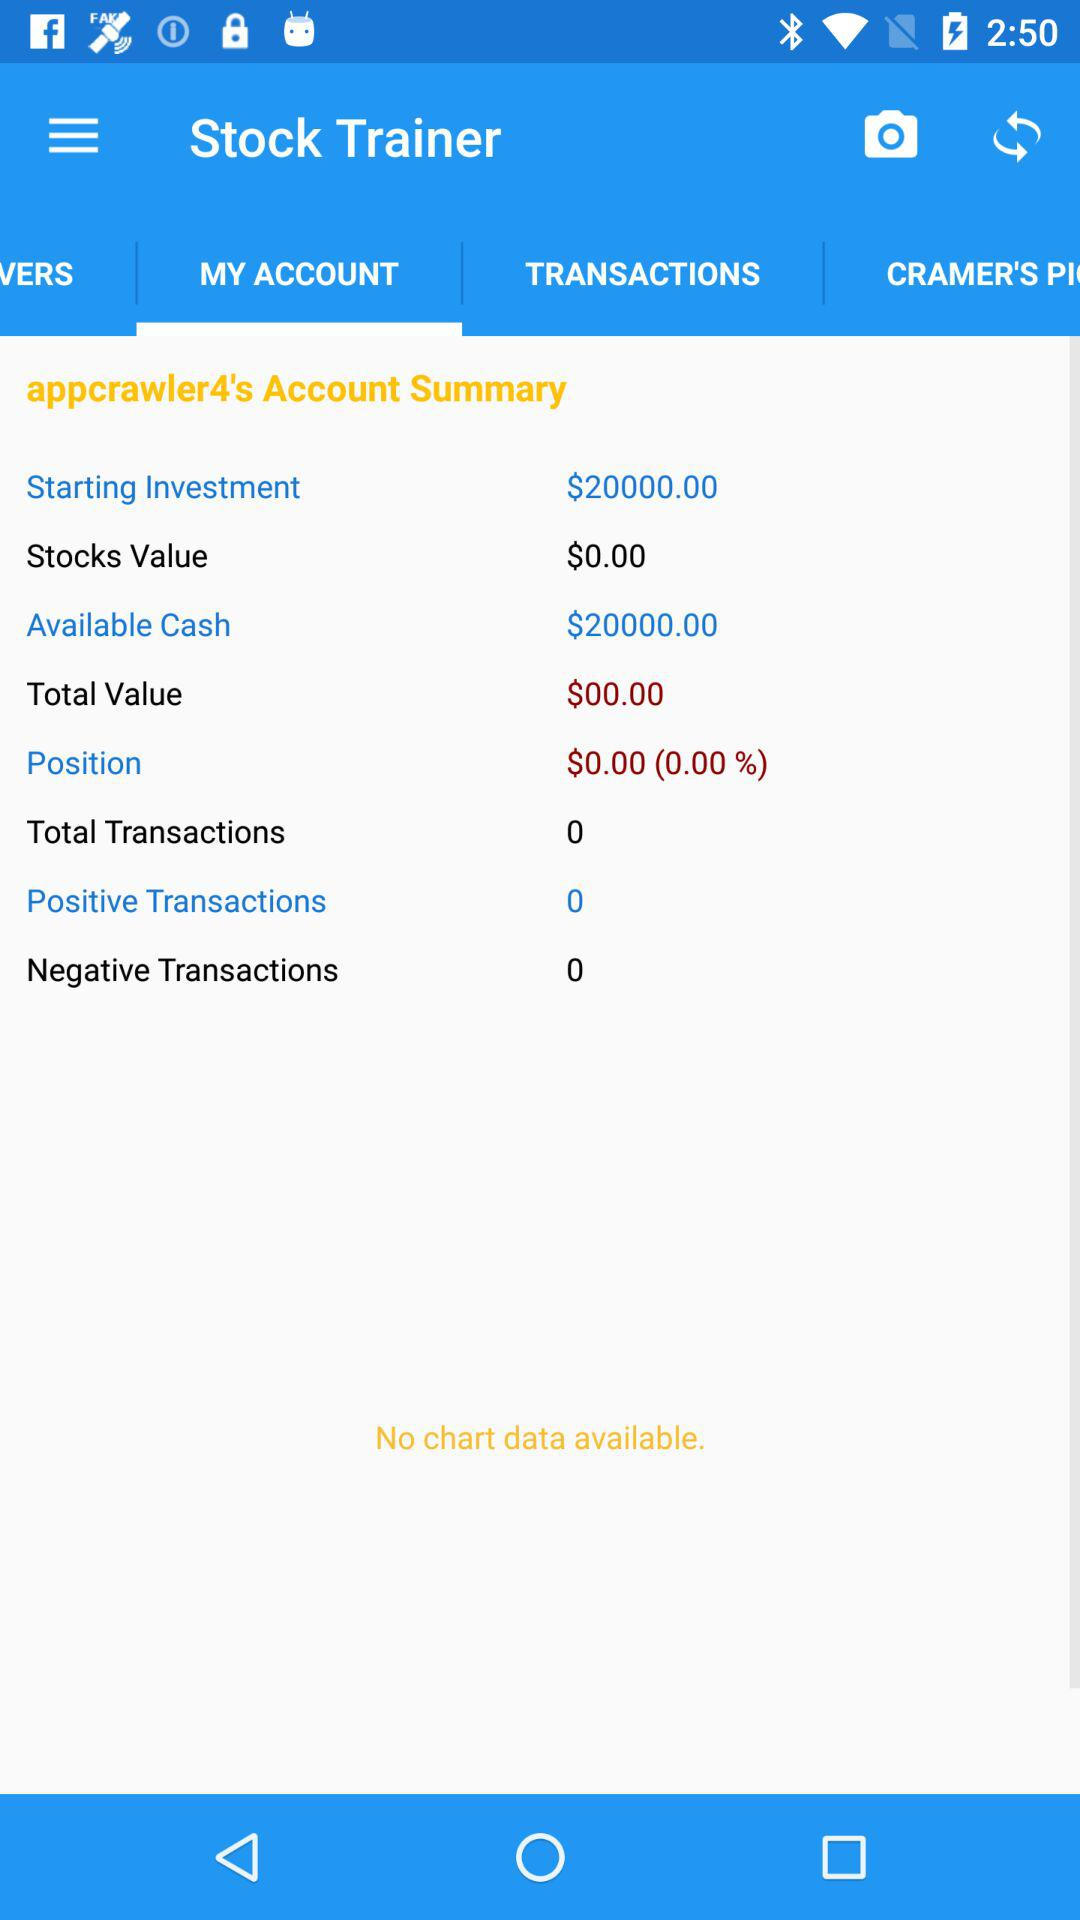What is the total value? The total value is $0. 